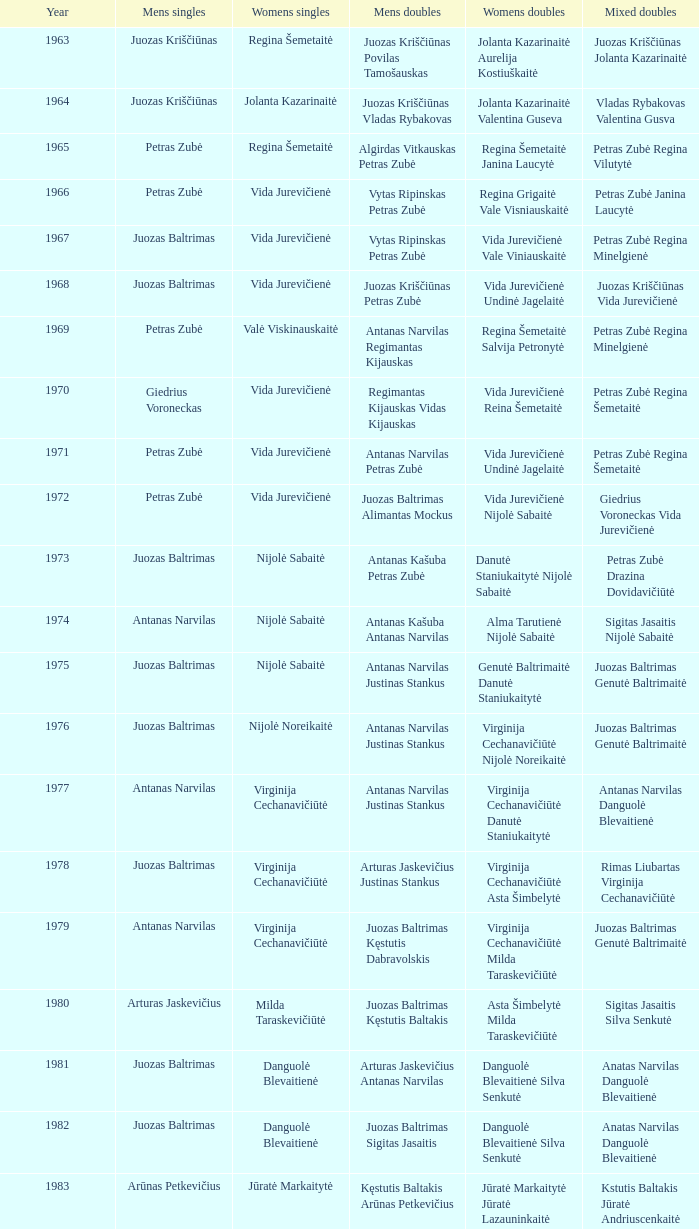How many years did aivaras kvedarauskas juozas spelveris participate in the men's doubles? 1.0. 